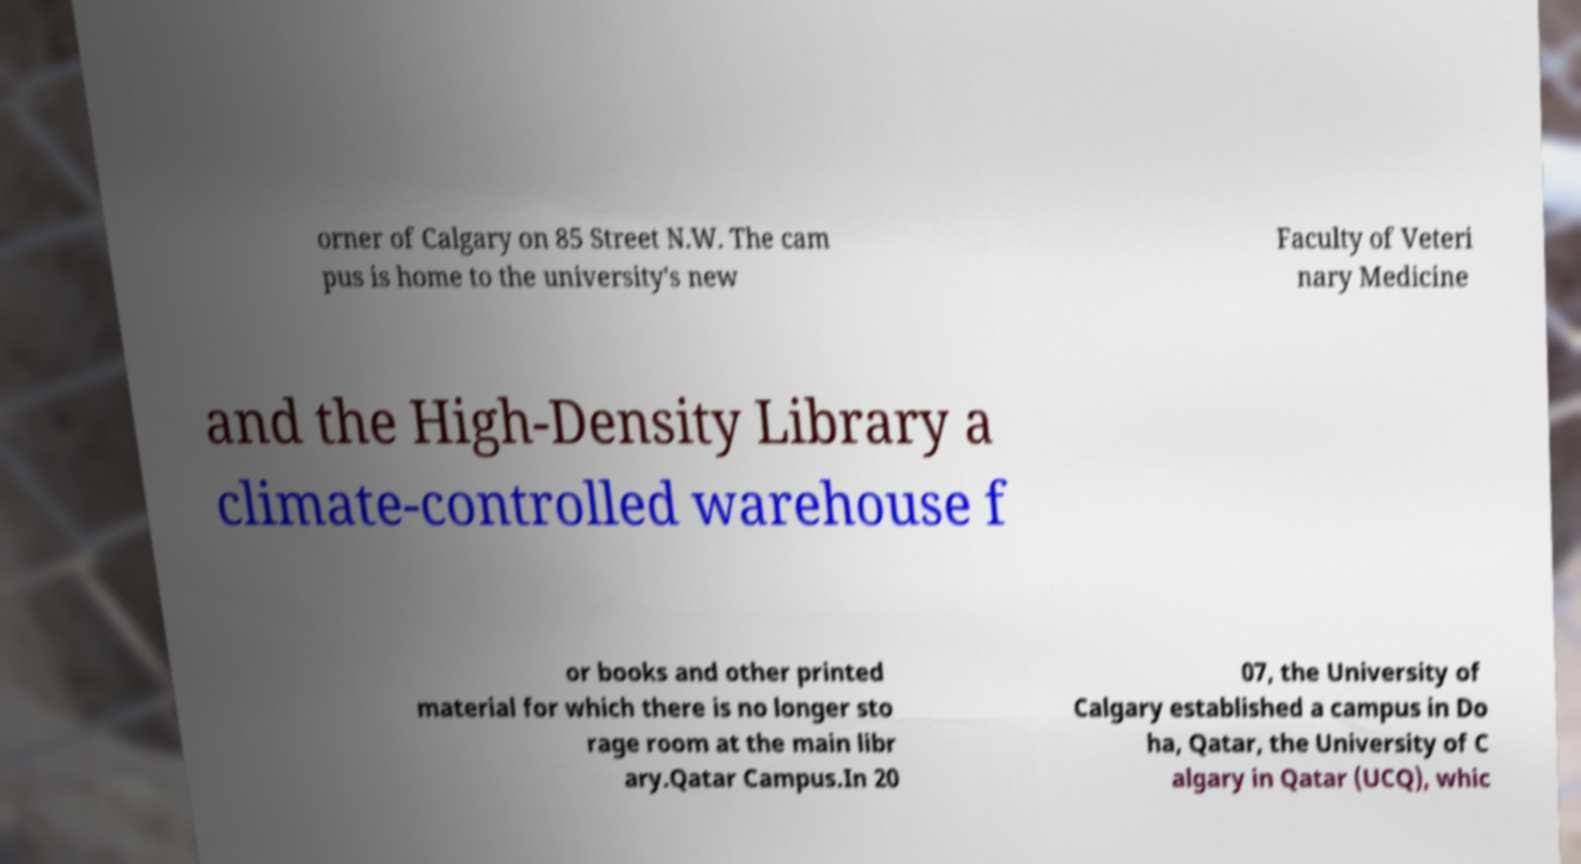I need the written content from this picture converted into text. Can you do that? orner of Calgary on 85 Street N.W. The cam pus is home to the university's new Faculty of Veteri nary Medicine and the High-Density Library a climate-controlled warehouse f or books and other printed material for which there is no longer sto rage room at the main libr ary.Qatar Campus.In 20 07, the University of Calgary established a campus in Do ha, Qatar, the University of C algary in Qatar (UCQ), whic 